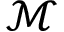<formula> <loc_0><loc_0><loc_500><loc_500>\mathcal { M }</formula> 